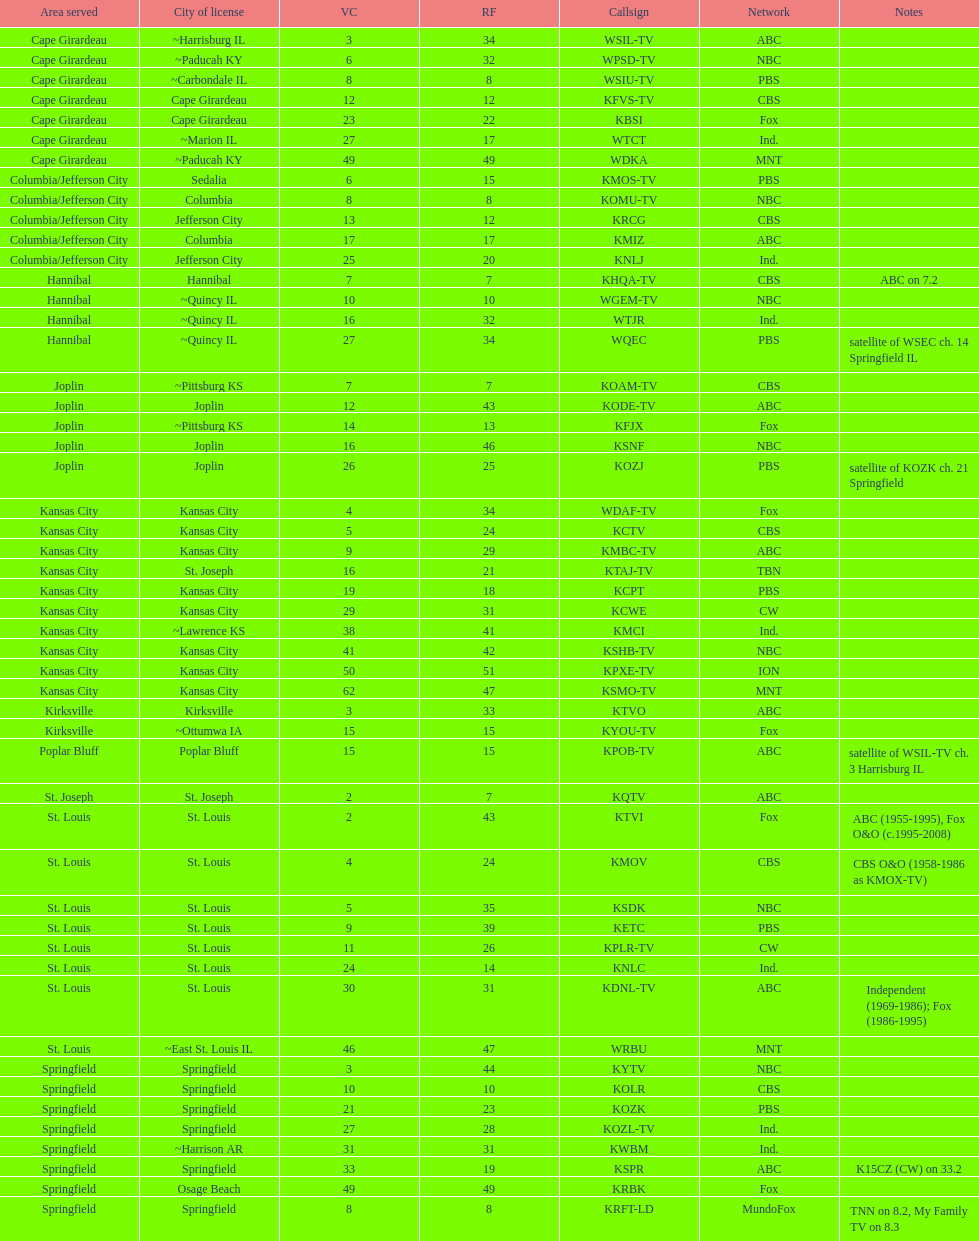Which station holds a license in the identical city as koam-tv? KFJX. 